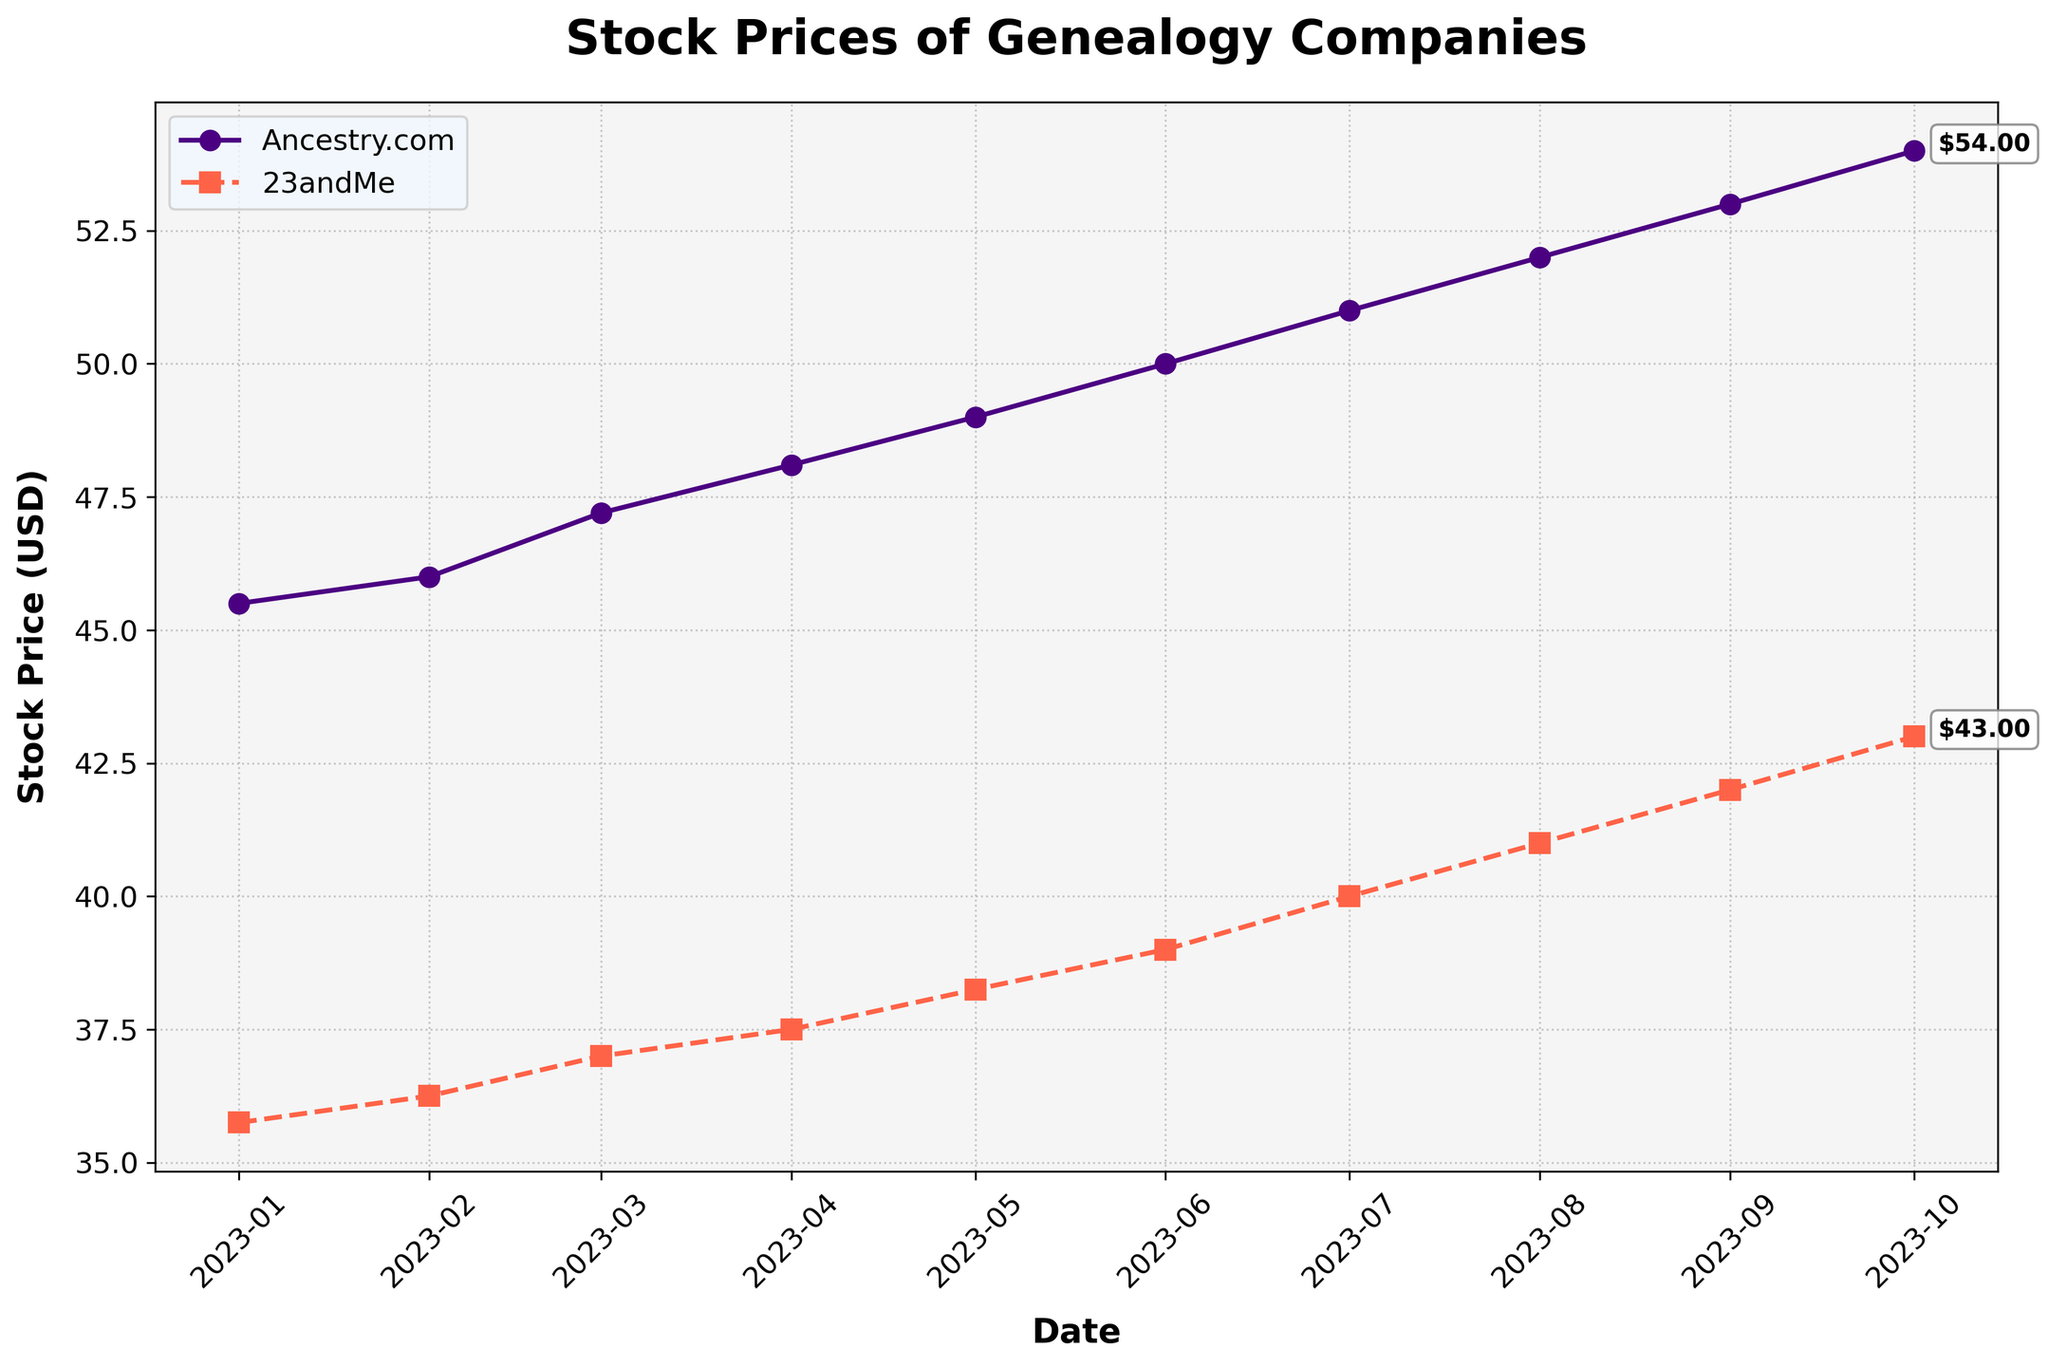What's the title of the plot? The title is located at the top center of the plot.
Answer: Stock Prices of Genealogy Companies Which company had the higher stock price on June 1, 2023? Locate the date "2023-06-01" on the x-axis and compare the two data points for Ancestry.com and 23andMe.
Answer: Ancestry.com What date did Ancestry.com's stock price reach 50 USD? Trace the line for Ancestry.com until the stock price reaches 50 on the y-axis, then look down at the corresponding date on the x-axis.
Answer: 2023-06-01 What is the difference in the stock prices between Ancestry.com and 23andMe on August 1, 2023? Look at the stock prices for each company on "2023-08-01" and subtract the smaller from the larger. Ancestry.com is at 52 and 23andMe is at 41.
Answer: 11 USD Which month shows the largest increase in stock price for 23andMe? Observe the stock prices for each month and identify the largest upward jump between consecutive points. The largest jump is between July and August (1 USD increment).
Answer: July to August What is the average stock price for Ancestry.com over the entire period? Sum the stock prices of Ancestry.com then divide by the number of data points. The prices are 45.50, 46.00, 47.20, 48.10, 49.00, 50.00, 51.00, 52.00, 53.00, 54.00; the sum is 495.80, and there are 10 data points.
Answer: 49.58 USD Which company shows a more stable trend in stock price? Compare the smoothness of the lines for both companies, noting the larger ups and downs. Ancestry.com has a smoother, less jagged line compared to 23andMe.
Answer: Ancestry.com What was the stock price of 23andMe on the first date shown in the plot? Find the left-most data point for 23andMe and read the y-axis value.
Answer: 35.75 USD How does the stock price trend of Ancestry.com from April to July compare to that of 23andMe in the same period? Compare the four data points for each company from April to July. Ancestry.com shows a steady rise each month (48.10, 49.00, 50.00, 51.00) while 23andMe also shows a rise but with smaller increments (37.50, 38.25, 39.00, 40.00).
Answer: Both increased, but Ancestry.com's increase was more pronounced By how much did 23andMe's stock price change from January to October 2023? Subtract the January stock price value for 23andMe from the October value. January value is 35.75, and October value is 43.00.
Answer: 7.25 USD 